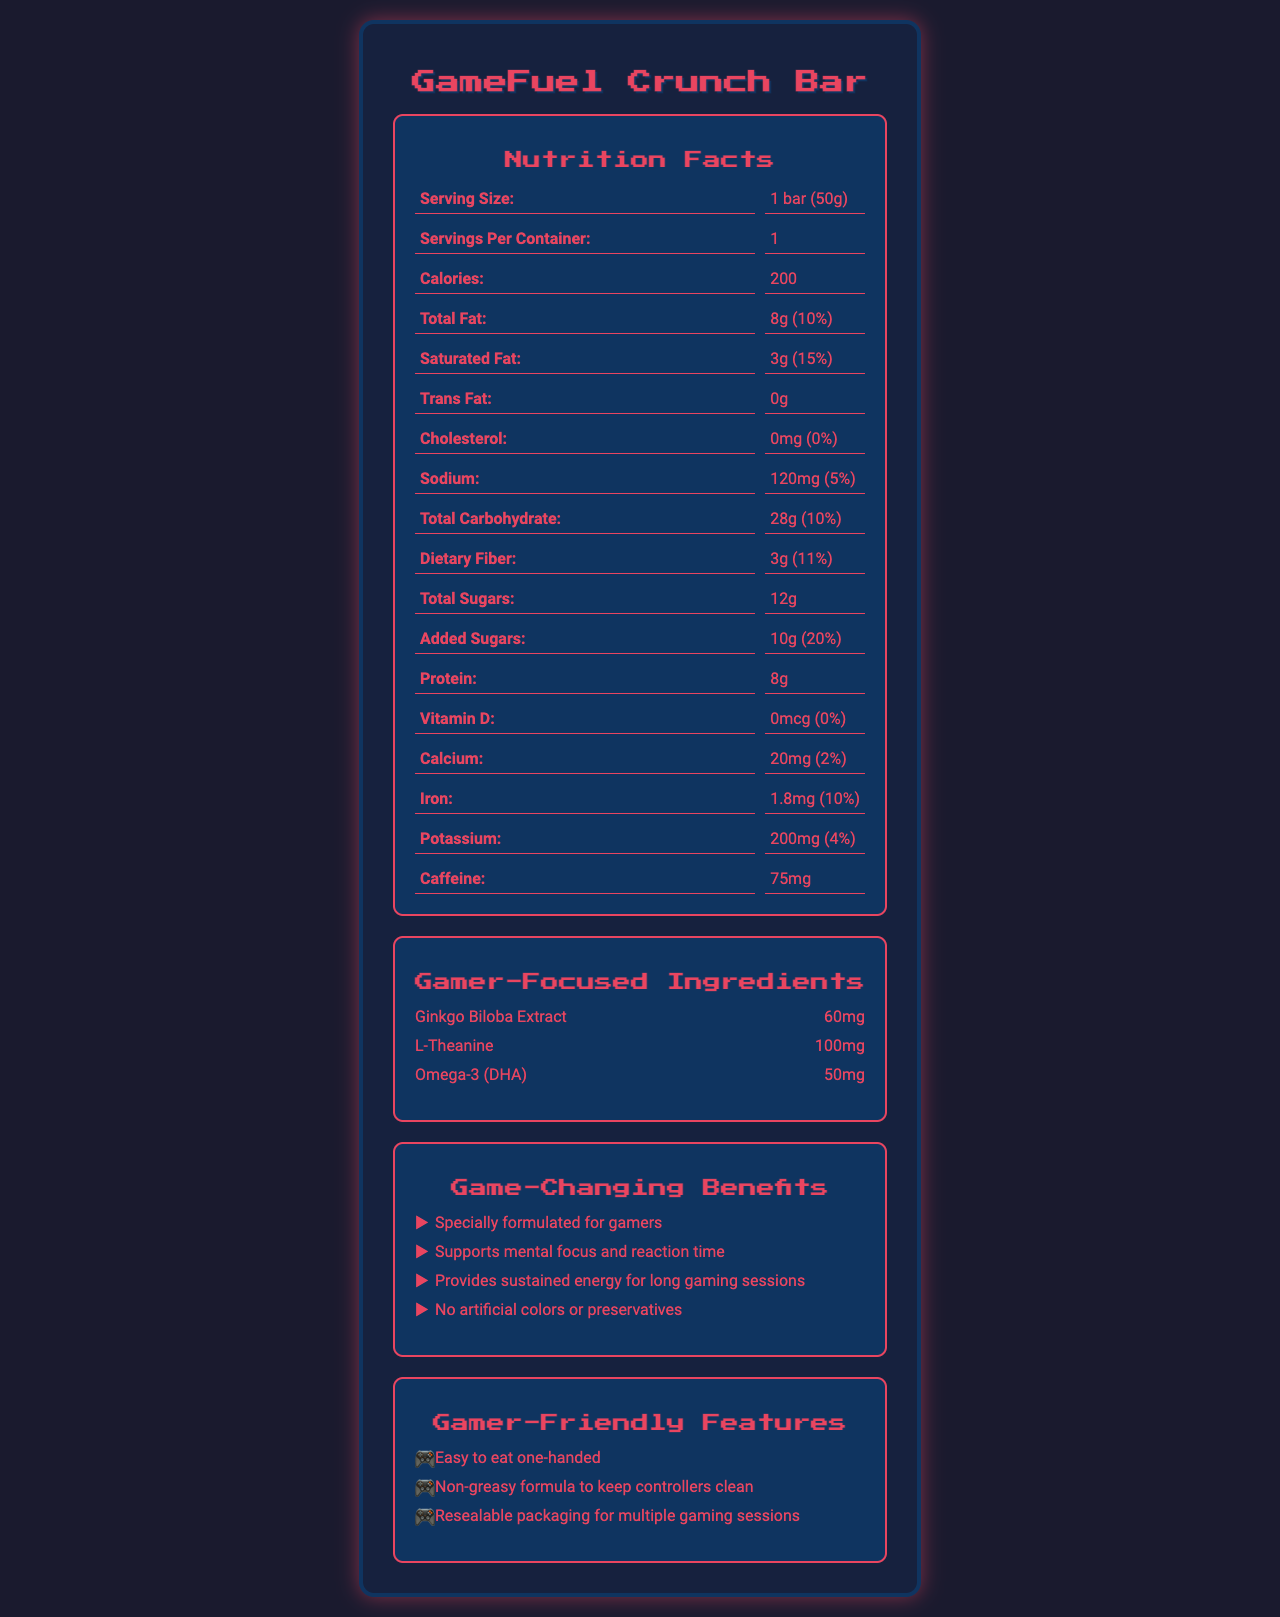What is the serving size for the GameFuel Crunch Bar? The document specifies that the serving size is 1 bar weighing 50 grams.
Answer: 1 bar (50g) How many calories are in one serving of the GameFuel Crunch Bar? According to the nutrition facts, there are 200 calories per serving.
Answer: 200 calories Which of the following is an ingredient listed under gamer-focused ingredients? A. Almonds B. Ginkgo Biloba Extract C. Cocoa Powder D. Sea Salt Ginkgo Biloba Extract is mentioned under gamer-focused ingredients while the others are listed under general ingredients.
Answer: B What is the main purpose of the GameFuel Crunch Bar according to the marketing claims? The document states that the bar is specially formulated for gamers and supports mental focus and reaction time.
Answer: Enhancing gaming focus and performance Does the GameFuel Crunch Bar contain any artificial colors or preservatives? The marketing claims explicitly mention that the bar contains no artificial colors or preservatives.
Answer: No How much caffeine is in one GameFuel Crunch Bar? The nutrition facts label includes 75mg of caffeine per bar.
Answer: 75mg What allergens does the GameFuel Crunch Bar contain? The document lists that the bar contains almonds and soy and may contain traces of peanuts and other tree nuts.
Answer: Almonds, Soy Which feature is mentioned about the GameFuel Crunch Bar's packaging? A. Biodegradable packaging B. Resealable packaging C. Transparent packaging D. Recyclable packaging The document mentions that the bar comes in resealable packaging for multiple gaming sessions.
Answer: B What is the maximum amount of added sugars in the GameFuel Crunch Bar in terms of daily value percentage? The added sugars amount to 10g, which is 20% of the daily value.
Answer: 20% Can the document confirm the exact amount of Omega-3 (DHA) in the GameFuel Crunch Bar? The document lists that the bar contains 50mg of Omega-3 (DHA).
Answer: Yes What are the main components of the GameFuel Crunch Bar's nutrition label? These components are all clearly itemized in the nutrition facts section.
Answer: Serving size, calories, total fat, saturated fat, trans fat, cholesterol, sodium, total carbohydrate, dietary fiber, total sugars, added sugars, protein, vitamin D, calcium, iron, potassium, caffeine Is there any information about how the GameFuel Crunch Bar tastes? The document does not provide any sensory information such as taste or flavor description.
Answer: Cannot be determined Summarize the main idea of the document. The document details the nutritional content, special ingredients, and functional benefits, highlighting how the product is tailored for gamers with convenient and clean packaging.
Answer: The document provides comprehensive nutrition facts, ingredient lists, and specialized claims for the GameFuel Crunch Bar, designed specifically for gamers to enhance focus and performance. The bar contains ingredients aimed at supporting mental focus, providing sustained energy, and is marketed as being free from artificial colors or preservatives with gamer-friendly packaging and features. 